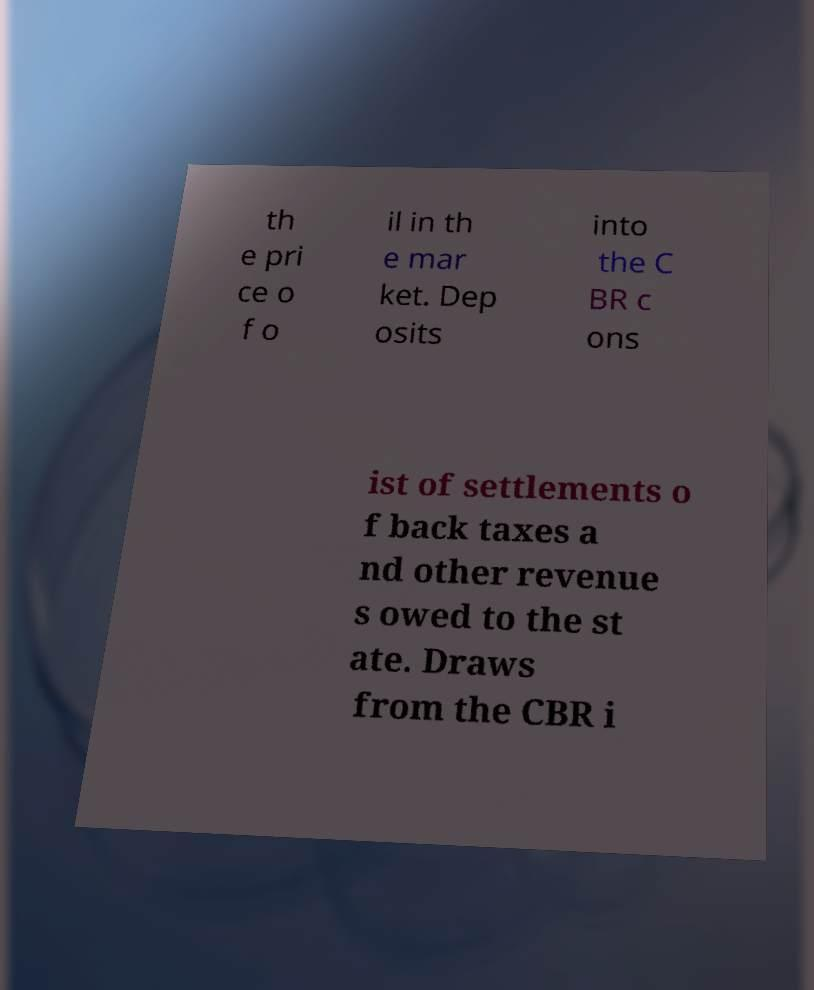Could you assist in decoding the text presented in this image and type it out clearly? th e pri ce o f o il in th e mar ket. Dep osits into the C BR c ons ist of settlements o f back taxes a nd other revenue s owed to the st ate. Draws from the CBR i 